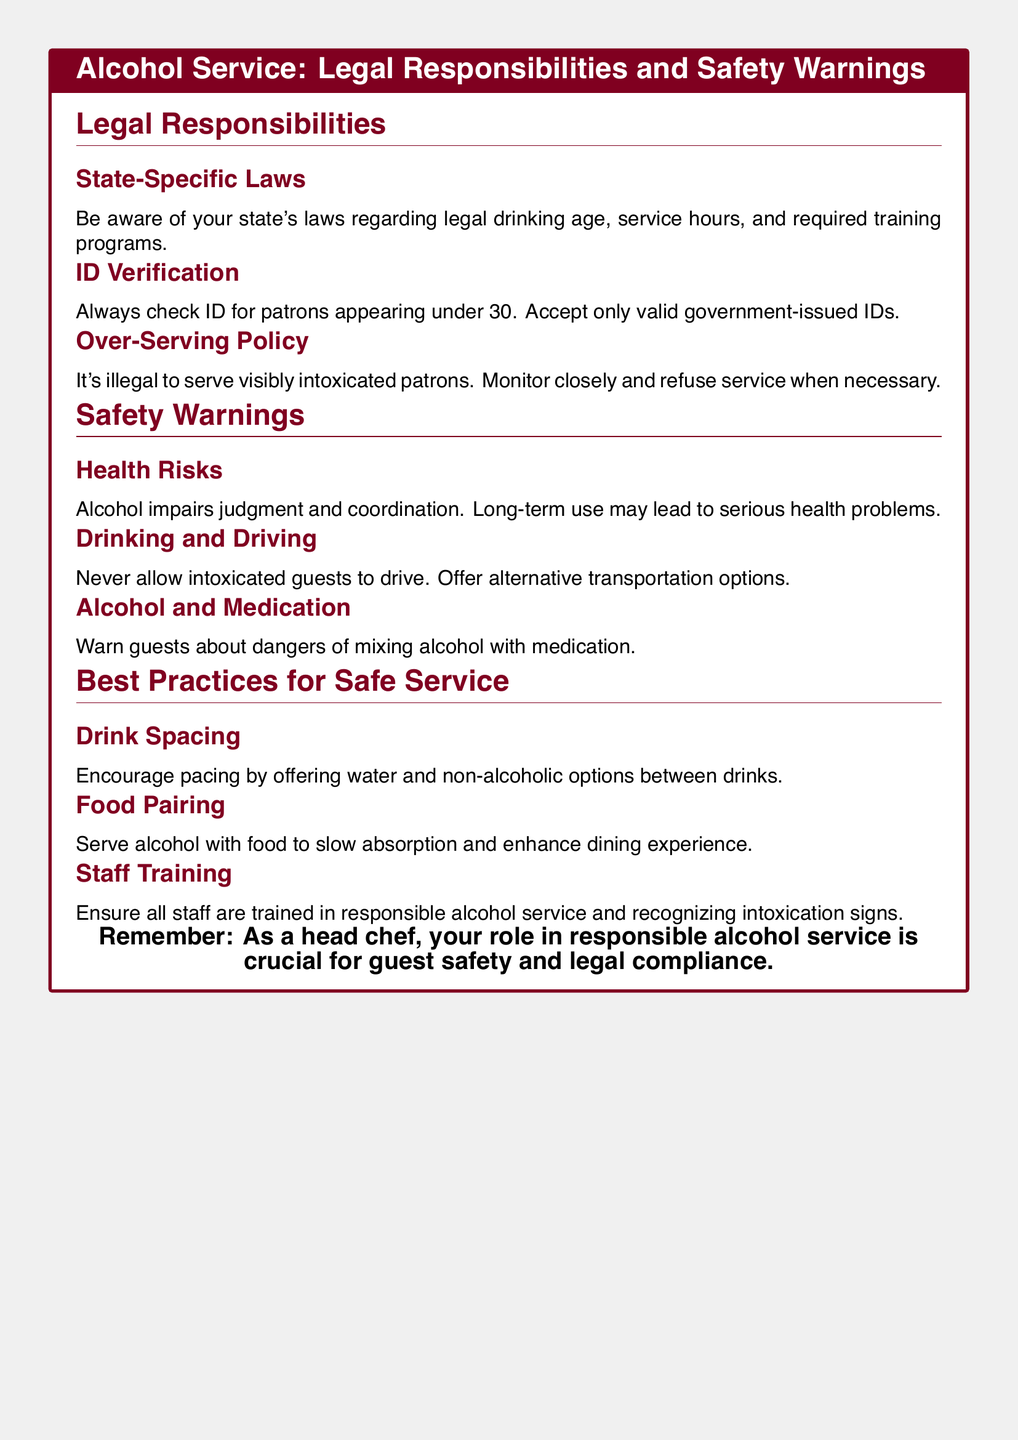What is the legal drinking age? The document highlights the importance of understanding state-specific laws but does not explicitly mention a number.
Answer: Varies by state What should you check for patrons appearing under 30? The document states that ID verification is mandatory for patrons appearing under 30.
Answer: ID What should you offer to intoxicated guests instead of allowing them to drive? The safety warnings include offering alternative transportation options.
Answer: Alternative transportation What is a health risk associated with alcohol? The document notes that alcohol impairs judgment and coordination and may lead to serious health problems.
Answer: Impaired judgment What does the document recommend to slow alcohol absorption? It suggests serving alcohol with food to enhance the dining experience and slow absorption.
Answer: Food How should staff be prepared for alcohol service? The document emphasizes that all staff should be trained in responsible alcohol service and recognizing intoxication signs.
Answer: Training What is illegal regarding serving visibly intoxicated patrons? The document states that it is illegal to serve visibly intoxicated patrons.
Answer: Illegal What is encouraged between drinks? The best practices section recommends encouraging pacing by offering water and non-alcoholic options.
Answer: Water and non-alcoholic options 